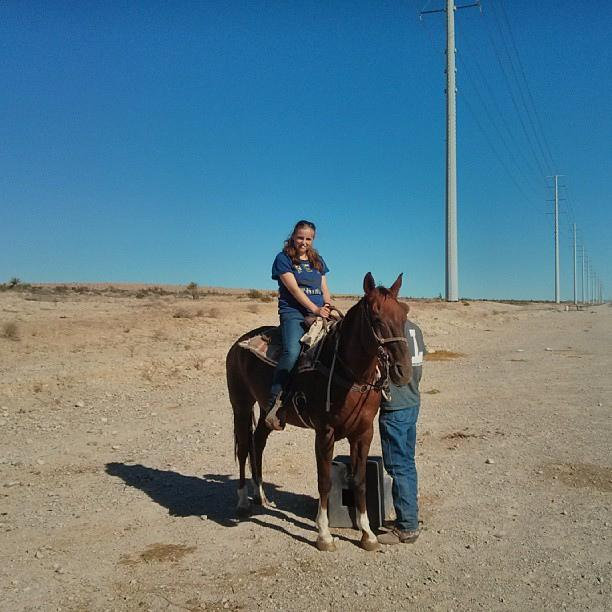If you want to use this transport what can you feed it? Please explain your reasoning. carrots. Horses eat orange vegetables as a treat. 